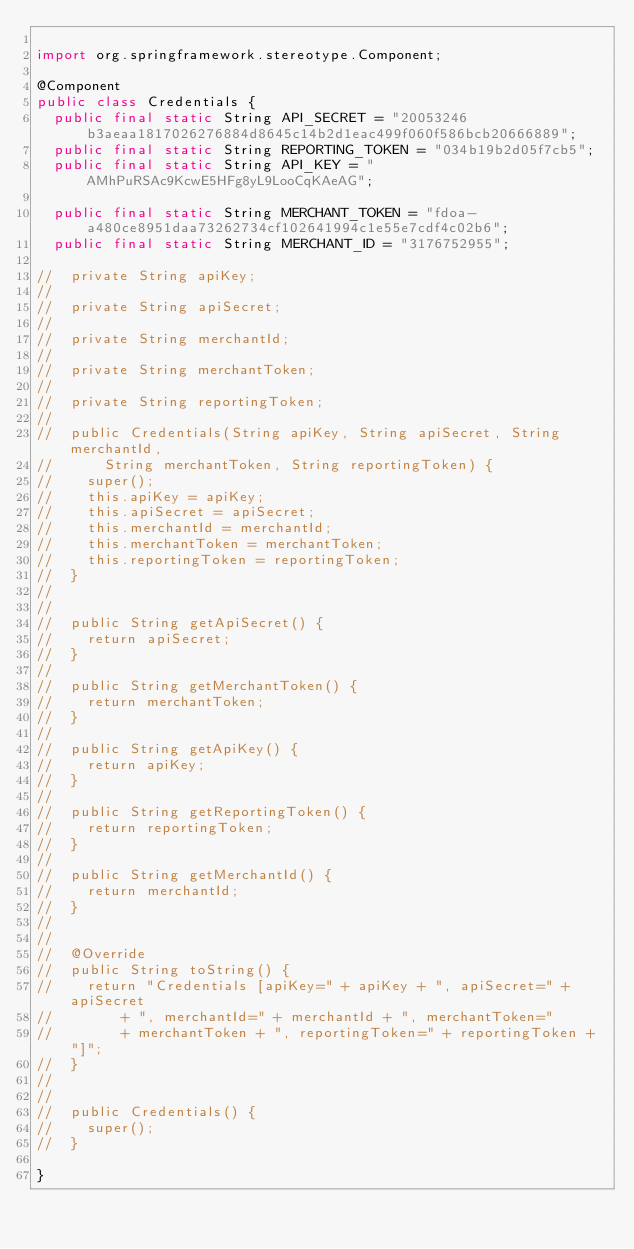Convert code to text. <code><loc_0><loc_0><loc_500><loc_500><_Java_>
import org.springframework.stereotype.Component;

@Component
public class Credentials {
	public final static String API_SECRET = "20053246b3aeaa1817026276884d8645c14b2d1eac499f060f586bcb20666889";
	public final static String REPORTING_TOKEN = "034b19b2d05f7cb5";
	public final static String API_KEY = "AMhPuRSAc9KcwE5HFg8yL9LooCqKAeAG";

	public final static String MERCHANT_TOKEN = "fdoa-a480ce8951daa73262734cf102641994c1e55e7cdf4c02b6";
	public final static String MERCHANT_ID = "3176752955";

//	private String apiKey;
//	
//	private String apiSecret;
//
//	private String merchantId;
//	
//	private String merchantToken;
//		
//	private String reportingToken;
//
//	public Credentials(String apiKey, String apiSecret, String merchantId,
//			String merchantToken, String reportingToken) {
//		super();
//		this.apiKey = apiKey;
//		this.apiSecret = apiSecret;
//		this.merchantId = merchantId;
//		this.merchantToken = merchantToken;
//		this.reportingToken = reportingToken;
//	}
//
//
//	public String getApiSecret() {
//		return apiSecret;
//	}
//
//	public String getMerchantToken() {
//		return merchantToken;
//	}
//
//	public String getApiKey() {
//		return apiKey;
//	}
//
//	public String getReportingToken() {
//		return reportingToken;
//	}
//
//	public String getMerchantId() {
//		return merchantId;
//	}
//
//
//	@Override
//	public String toString() {
//		return "Credentials [apiKey=" + apiKey + ", apiSecret=" + apiSecret
//				+ ", merchantId=" + merchantId + ", merchantToken="
//				+ merchantToken + ", reportingToken=" + reportingToken + "]";
//	}
//
//
//	public Credentials() {
//		super();
//	}
	
}
	

</code> 